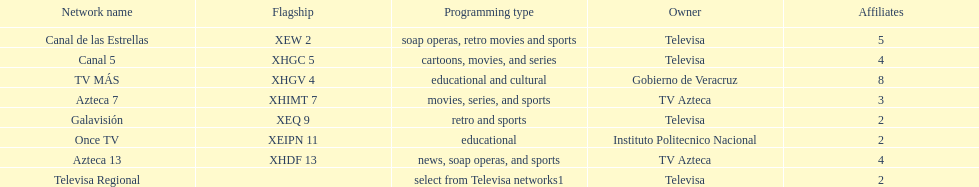Can you provide the quantity of stations that tv azteca possesses? 2. 